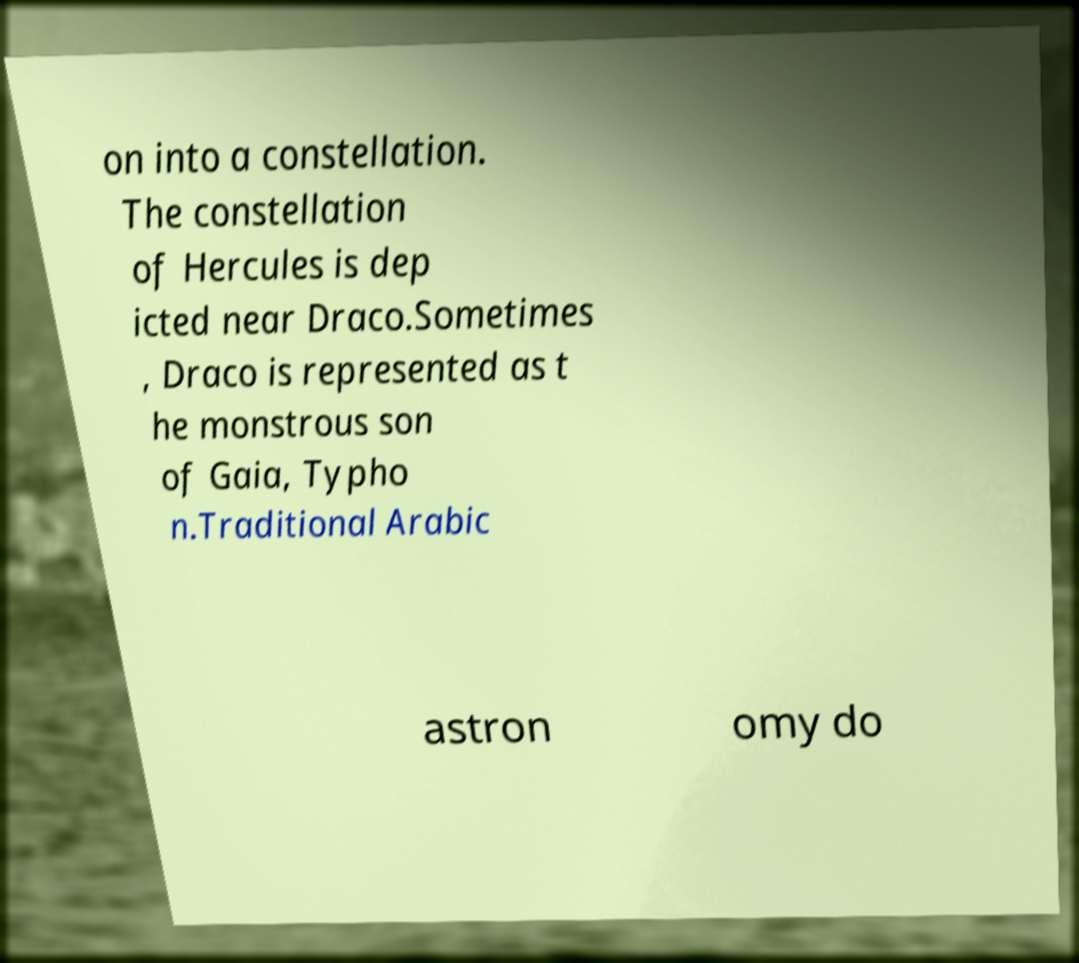Could you extract and type out the text from this image? on into a constellation. The constellation of Hercules is dep icted near Draco.Sometimes , Draco is represented as t he monstrous son of Gaia, Typho n.Traditional Arabic astron omy do 